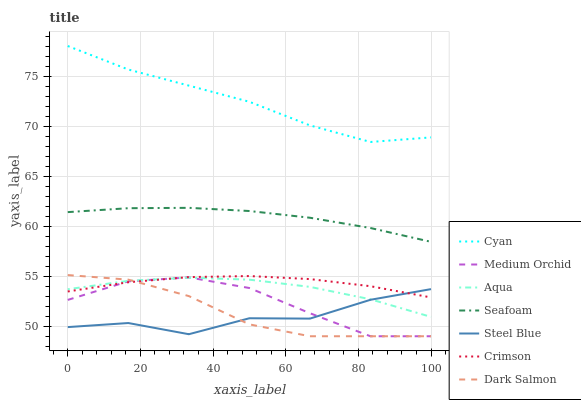Does Steel Blue have the minimum area under the curve?
Answer yes or no. Yes. Does Cyan have the maximum area under the curve?
Answer yes or no. Yes. Does Aqua have the minimum area under the curve?
Answer yes or no. No. Does Aqua have the maximum area under the curve?
Answer yes or no. No. Is Seafoam the smoothest?
Answer yes or no. Yes. Is Steel Blue the roughest?
Answer yes or no. Yes. Is Aqua the smoothest?
Answer yes or no. No. Is Aqua the roughest?
Answer yes or no. No. Does Aqua have the lowest value?
Answer yes or no. No. Does Cyan have the highest value?
Answer yes or no. Yes. Does Aqua have the highest value?
Answer yes or no. No. Is Dark Salmon less than Seafoam?
Answer yes or no. Yes. Is Seafoam greater than Medium Orchid?
Answer yes or no. Yes. Does Medium Orchid intersect Steel Blue?
Answer yes or no. Yes. Is Medium Orchid less than Steel Blue?
Answer yes or no. No. Is Medium Orchid greater than Steel Blue?
Answer yes or no. No. Does Dark Salmon intersect Seafoam?
Answer yes or no. No. 